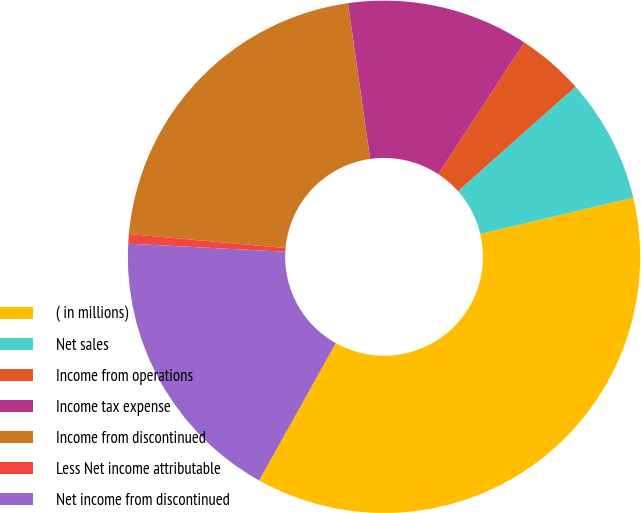Convert chart. <chart><loc_0><loc_0><loc_500><loc_500><pie_chart><fcel>( in millions)<fcel>Net sales<fcel>Income from operations<fcel>Income tax expense<fcel>Income from discontinued<fcel>Less Net income attributable<fcel>Net income from discontinued<nl><fcel>36.81%<fcel>7.85%<fcel>4.22%<fcel>11.47%<fcel>21.33%<fcel>0.6%<fcel>17.71%<nl></chart> 